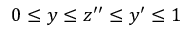Convert formula to latex. <formula><loc_0><loc_0><loc_500><loc_500>0 \leq y \leq z ^ { \prime \prime } \leq y ^ { \prime } \leq 1</formula> 